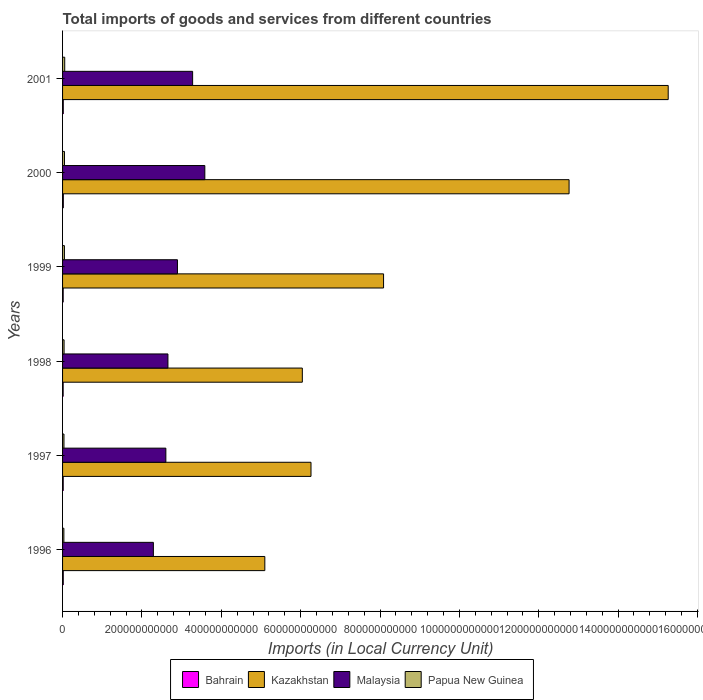How many groups of bars are there?
Give a very brief answer. 6. Are the number of bars per tick equal to the number of legend labels?
Provide a short and direct response. Yes. Are the number of bars on each tick of the Y-axis equal?
Your answer should be compact. Yes. How many bars are there on the 1st tick from the top?
Your response must be concise. 4. How many bars are there on the 5th tick from the bottom?
Offer a very short reply. 4. In how many cases, is the number of bars for a given year not equal to the number of legend labels?
Make the answer very short. 0. What is the Amount of goods and services imports in Papua New Guinea in 1998?
Give a very brief answer. 3.81e+09. Across all years, what is the maximum Amount of goods and services imports in Papua New Guinea?
Your response must be concise. 5.43e+09. Across all years, what is the minimum Amount of goods and services imports in Bahrain?
Offer a terse response. 1.49e+09. In which year was the Amount of goods and services imports in Kazakhstan maximum?
Make the answer very short. 2001. In which year was the Amount of goods and services imports in Malaysia minimum?
Keep it short and to the point. 1996. What is the total Amount of goods and services imports in Bahrain in the graph?
Give a very brief answer. 1.02e+1. What is the difference between the Amount of goods and services imports in Kazakhstan in 1997 and that in 1998?
Your answer should be very brief. 2.19e+1. What is the difference between the Amount of goods and services imports in Papua New Guinea in 1996 and the Amount of goods and services imports in Kazakhstan in 1999?
Provide a short and direct response. -8.06e+11. What is the average Amount of goods and services imports in Papua New Guinea per year?
Keep it short and to the point. 4.26e+09. In the year 2000, what is the difference between the Amount of goods and services imports in Malaysia and Amount of goods and services imports in Papua New Guinea?
Provide a short and direct response. 3.54e+11. In how many years, is the Amount of goods and services imports in Papua New Guinea greater than 1520000000000 LCU?
Your answer should be very brief. 0. What is the ratio of the Amount of goods and services imports in Papua New Guinea in 1996 to that in 2000?
Your response must be concise. 0.69. Is the difference between the Amount of goods and services imports in Malaysia in 1998 and 1999 greater than the difference between the Amount of goods and services imports in Papua New Guinea in 1998 and 1999?
Your answer should be very brief. No. What is the difference between the highest and the second highest Amount of goods and services imports in Papua New Guinea?
Offer a very short reply. 6.38e+08. What is the difference between the highest and the lowest Amount of goods and services imports in Kazakhstan?
Ensure brevity in your answer.  1.02e+12. Is the sum of the Amount of goods and services imports in Papua New Guinea in 1999 and 2000 greater than the maximum Amount of goods and services imports in Bahrain across all years?
Provide a succinct answer. Yes. What does the 3rd bar from the top in 1996 represents?
Offer a terse response. Kazakhstan. What does the 1st bar from the bottom in 2000 represents?
Provide a short and direct response. Bahrain. Is it the case that in every year, the sum of the Amount of goods and services imports in Kazakhstan and Amount of goods and services imports in Bahrain is greater than the Amount of goods and services imports in Malaysia?
Give a very brief answer. Yes. How many years are there in the graph?
Offer a very short reply. 6. What is the difference between two consecutive major ticks on the X-axis?
Provide a succinct answer. 2.00e+11. Does the graph contain any zero values?
Offer a very short reply. No. How are the legend labels stacked?
Provide a short and direct response. Horizontal. What is the title of the graph?
Ensure brevity in your answer.  Total imports of goods and services from different countries. What is the label or title of the X-axis?
Ensure brevity in your answer.  Imports (in Local Currency Unit). What is the label or title of the Y-axis?
Ensure brevity in your answer.  Years. What is the Imports (in Local Currency Unit) of Bahrain in 1996?
Your answer should be very brief. 1.75e+09. What is the Imports (in Local Currency Unit) in Kazakhstan in 1996?
Make the answer very short. 5.10e+11. What is the Imports (in Local Currency Unit) in Malaysia in 1996?
Your answer should be compact. 2.29e+11. What is the Imports (in Local Currency Unit) in Papua New Guinea in 1996?
Give a very brief answer. 3.29e+09. What is the Imports (in Local Currency Unit) of Bahrain in 1997?
Keep it short and to the point. 1.66e+09. What is the Imports (in Local Currency Unit) of Kazakhstan in 1997?
Provide a short and direct response. 6.26e+11. What is the Imports (in Local Currency Unit) in Malaysia in 1997?
Your answer should be very brief. 2.60e+11. What is the Imports (in Local Currency Unit) of Papua New Guinea in 1997?
Keep it short and to the point. 3.54e+09. What is the Imports (in Local Currency Unit) of Bahrain in 1998?
Ensure brevity in your answer.  1.49e+09. What is the Imports (in Local Currency Unit) in Kazakhstan in 1998?
Offer a terse response. 6.04e+11. What is the Imports (in Local Currency Unit) in Malaysia in 1998?
Keep it short and to the point. 2.66e+11. What is the Imports (in Local Currency Unit) in Papua New Guinea in 1998?
Provide a succinct answer. 3.81e+09. What is the Imports (in Local Currency Unit) of Bahrain in 1999?
Your response must be concise. 1.57e+09. What is the Imports (in Local Currency Unit) of Kazakhstan in 1999?
Offer a terse response. 8.09e+11. What is the Imports (in Local Currency Unit) in Malaysia in 1999?
Your answer should be very brief. 2.90e+11. What is the Imports (in Local Currency Unit) of Papua New Guinea in 1999?
Your answer should be very brief. 4.67e+09. What is the Imports (in Local Currency Unit) in Bahrain in 2000?
Ensure brevity in your answer.  1.93e+09. What is the Imports (in Local Currency Unit) in Kazakhstan in 2000?
Provide a short and direct response. 1.28e+12. What is the Imports (in Local Currency Unit) in Malaysia in 2000?
Ensure brevity in your answer.  3.59e+11. What is the Imports (in Local Currency Unit) in Papua New Guinea in 2000?
Provide a succinct answer. 4.79e+09. What is the Imports (in Local Currency Unit) in Bahrain in 2001?
Your response must be concise. 1.80e+09. What is the Imports (in Local Currency Unit) in Kazakhstan in 2001?
Your response must be concise. 1.53e+12. What is the Imports (in Local Currency Unit) in Malaysia in 2001?
Your response must be concise. 3.28e+11. What is the Imports (in Local Currency Unit) of Papua New Guinea in 2001?
Ensure brevity in your answer.  5.43e+09. Across all years, what is the maximum Imports (in Local Currency Unit) in Bahrain?
Your answer should be compact. 1.93e+09. Across all years, what is the maximum Imports (in Local Currency Unit) of Kazakhstan?
Make the answer very short. 1.53e+12. Across all years, what is the maximum Imports (in Local Currency Unit) of Malaysia?
Ensure brevity in your answer.  3.59e+11. Across all years, what is the maximum Imports (in Local Currency Unit) in Papua New Guinea?
Make the answer very short. 5.43e+09. Across all years, what is the minimum Imports (in Local Currency Unit) in Bahrain?
Your response must be concise. 1.49e+09. Across all years, what is the minimum Imports (in Local Currency Unit) in Kazakhstan?
Provide a short and direct response. 5.10e+11. Across all years, what is the minimum Imports (in Local Currency Unit) in Malaysia?
Provide a short and direct response. 2.29e+11. Across all years, what is the minimum Imports (in Local Currency Unit) of Papua New Guinea?
Ensure brevity in your answer.  3.29e+09. What is the total Imports (in Local Currency Unit) in Bahrain in the graph?
Ensure brevity in your answer.  1.02e+1. What is the total Imports (in Local Currency Unit) of Kazakhstan in the graph?
Offer a terse response. 5.35e+12. What is the total Imports (in Local Currency Unit) in Malaysia in the graph?
Offer a very short reply. 1.73e+12. What is the total Imports (in Local Currency Unit) of Papua New Guinea in the graph?
Make the answer very short. 2.55e+1. What is the difference between the Imports (in Local Currency Unit) in Bahrain in 1996 and that in 1997?
Give a very brief answer. 8.90e+07. What is the difference between the Imports (in Local Currency Unit) of Kazakhstan in 1996 and that in 1997?
Your response must be concise. -1.16e+11. What is the difference between the Imports (in Local Currency Unit) in Malaysia in 1996 and that in 1997?
Offer a terse response. -3.15e+1. What is the difference between the Imports (in Local Currency Unit) of Papua New Guinea in 1996 and that in 1997?
Keep it short and to the point. -2.55e+08. What is the difference between the Imports (in Local Currency Unit) of Bahrain in 1996 and that in 1998?
Give a very brief answer. 2.63e+08. What is the difference between the Imports (in Local Currency Unit) in Kazakhstan in 1996 and that in 1998?
Give a very brief answer. -9.45e+1. What is the difference between the Imports (in Local Currency Unit) of Malaysia in 1996 and that in 1998?
Your answer should be compact. -3.67e+1. What is the difference between the Imports (in Local Currency Unit) of Papua New Guinea in 1996 and that in 1998?
Provide a short and direct response. -5.21e+08. What is the difference between the Imports (in Local Currency Unit) of Bahrain in 1996 and that in 1999?
Offer a very short reply. 1.81e+08. What is the difference between the Imports (in Local Currency Unit) in Kazakhstan in 1996 and that in 1999?
Offer a very short reply. -2.99e+11. What is the difference between the Imports (in Local Currency Unit) in Malaysia in 1996 and that in 1999?
Your answer should be very brief. -6.07e+1. What is the difference between the Imports (in Local Currency Unit) of Papua New Guinea in 1996 and that in 1999?
Keep it short and to the point. -1.38e+09. What is the difference between the Imports (in Local Currency Unit) in Bahrain in 1996 and that in 2000?
Make the answer very short. -1.81e+08. What is the difference between the Imports (in Local Currency Unit) of Kazakhstan in 1996 and that in 2000?
Provide a succinct answer. -7.67e+11. What is the difference between the Imports (in Local Currency Unit) of Malaysia in 1996 and that in 2000?
Offer a terse response. -1.30e+11. What is the difference between the Imports (in Local Currency Unit) in Papua New Guinea in 1996 and that in 2000?
Make the answer very short. -1.51e+09. What is the difference between the Imports (in Local Currency Unit) of Bahrain in 1996 and that in 2001?
Give a very brief answer. -5.45e+07. What is the difference between the Imports (in Local Currency Unit) in Kazakhstan in 1996 and that in 2001?
Make the answer very short. -1.02e+12. What is the difference between the Imports (in Local Currency Unit) in Malaysia in 1996 and that in 2001?
Give a very brief answer. -9.89e+1. What is the difference between the Imports (in Local Currency Unit) in Papua New Guinea in 1996 and that in 2001?
Your response must be concise. -2.14e+09. What is the difference between the Imports (in Local Currency Unit) in Bahrain in 1997 and that in 1998?
Your answer should be compact. 1.74e+08. What is the difference between the Imports (in Local Currency Unit) in Kazakhstan in 1997 and that in 1998?
Ensure brevity in your answer.  2.19e+1. What is the difference between the Imports (in Local Currency Unit) in Malaysia in 1997 and that in 1998?
Keep it short and to the point. -5.23e+09. What is the difference between the Imports (in Local Currency Unit) in Papua New Guinea in 1997 and that in 1998?
Your answer should be compact. -2.66e+08. What is the difference between the Imports (in Local Currency Unit) of Bahrain in 1997 and that in 1999?
Your response must be concise. 9.18e+07. What is the difference between the Imports (in Local Currency Unit) in Kazakhstan in 1997 and that in 1999?
Offer a terse response. -1.83e+11. What is the difference between the Imports (in Local Currency Unit) in Malaysia in 1997 and that in 1999?
Offer a very short reply. -2.92e+1. What is the difference between the Imports (in Local Currency Unit) of Papua New Guinea in 1997 and that in 1999?
Your response must be concise. -1.13e+09. What is the difference between the Imports (in Local Currency Unit) in Bahrain in 1997 and that in 2000?
Make the answer very short. -2.70e+08. What is the difference between the Imports (in Local Currency Unit) of Kazakhstan in 1997 and that in 2000?
Your answer should be compact. -6.50e+11. What is the difference between the Imports (in Local Currency Unit) in Malaysia in 1997 and that in 2000?
Your response must be concise. -9.82e+1. What is the difference between the Imports (in Local Currency Unit) in Papua New Guinea in 1997 and that in 2000?
Make the answer very short. -1.25e+09. What is the difference between the Imports (in Local Currency Unit) of Bahrain in 1997 and that in 2001?
Keep it short and to the point. -1.44e+08. What is the difference between the Imports (in Local Currency Unit) of Kazakhstan in 1997 and that in 2001?
Your answer should be compact. -9.00e+11. What is the difference between the Imports (in Local Currency Unit) of Malaysia in 1997 and that in 2001?
Offer a terse response. -6.75e+1. What is the difference between the Imports (in Local Currency Unit) in Papua New Guinea in 1997 and that in 2001?
Offer a terse response. -1.89e+09. What is the difference between the Imports (in Local Currency Unit) of Bahrain in 1998 and that in 1999?
Give a very brief answer. -8.21e+07. What is the difference between the Imports (in Local Currency Unit) of Kazakhstan in 1998 and that in 1999?
Your response must be concise. -2.05e+11. What is the difference between the Imports (in Local Currency Unit) of Malaysia in 1998 and that in 1999?
Offer a very short reply. -2.40e+1. What is the difference between the Imports (in Local Currency Unit) of Papua New Guinea in 1998 and that in 1999?
Provide a succinct answer. -8.59e+08. What is the difference between the Imports (in Local Currency Unit) of Bahrain in 1998 and that in 2000?
Provide a succinct answer. -4.44e+08. What is the difference between the Imports (in Local Currency Unit) in Kazakhstan in 1998 and that in 2000?
Offer a very short reply. -6.72e+11. What is the difference between the Imports (in Local Currency Unit) in Malaysia in 1998 and that in 2000?
Provide a short and direct response. -9.30e+1. What is the difference between the Imports (in Local Currency Unit) in Papua New Guinea in 1998 and that in 2000?
Offer a very short reply. -9.85e+08. What is the difference between the Imports (in Local Currency Unit) in Bahrain in 1998 and that in 2001?
Your response must be concise. -3.17e+08. What is the difference between the Imports (in Local Currency Unit) in Kazakhstan in 1998 and that in 2001?
Your answer should be compact. -9.22e+11. What is the difference between the Imports (in Local Currency Unit) of Malaysia in 1998 and that in 2001?
Provide a short and direct response. -6.22e+1. What is the difference between the Imports (in Local Currency Unit) of Papua New Guinea in 1998 and that in 2001?
Ensure brevity in your answer.  -1.62e+09. What is the difference between the Imports (in Local Currency Unit) in Bahrain in 1999 and that in 2000?
Provide a short and direct response. -3.62e+08. What is the difference between the Imports (in Local Currency Unit) of Kazakhstan in 1999 and that in 2000?
Offer a terse response. -4.68e+11. What is the difference between the Imports (in Local Currency Unit) in Malaysia in 1999 and that in 2000?
Your answer should be compact. -6.90e+1. What is the difference between the Imports (in Local Currency Unit) in Papua New Guinea in 1999 and that in 2000?
Your answer should be compact. -1.25e+08. What is the difference between the Imports (in Local Currency Unit) in Bahrain in 1999 and that in 2001?
Offer a very short reply. -2.35e+08. What is the difference between the Imports (in Local Currency Unit) of Kazakhstan in 1999 and that in 2001?
Make the answer very short. -7.17e+11. What is the difference between the Imports (in Local Currency Unit) of Malaysia in 1999 and that in 2001?
Offer a very short reply. -3.83e+1. What is the difference between the Imports (in Local Currency Unit) of Papua New Guinea in 1999 and that in 2001?
Give a very brief answer. -7.63e+08. What is the difference between the Imports (in Local Currency Unit) in Bahrain in 2000 and that in 2001?
Provide a succinct answer. 1.27e+08. What is the difference between the Imports (in Local Currency Unit) of Kazakhstan in 2000 and that in 2001?
Your answer should be very brief. -2.50e+11. What is the difference between the Imports (in Local Currency Unit) of Malaysia in 2000 and that in 2001?
Ensure brevity in your answer.  3.08e+1. What is the difference between the Imports (in Local Currency Unit) in Papua New Guinea in 2000 and that in 2001?
Your response must be concise. -6.38e+08. What is the difference between the Imports (in Local Currency Unit) in Bahrain in 1996 and the Imports (in Local Currency Unit) in Kazakhstan in 1997?
Your answer should be very brief. -6.24e+11. What is the difference between the Imports (in Local Currency Unit) in Bahrain in 1996 and the Imports (in Local Currency Unit) in Malaysia in 1997?
Ensure brevity in your answer.  -2.59e+11. What is the difference between the Imports (in Local Currency Unit) of Bahrain in 1996 and the Imports (in Local Currency Unit) of Papua New Guinea in 1997?
Keep it short and to the point. -1.80e+09. What is the difference between the Imports (in Local Currency Unit) of Kazakhstan in 1996 and the Imports (in Local Currency Unit) of Malaysia in 1997?
Keep it short and to the point. 2.49e+11. What is the difference between the Imports (in Local Currency Unit) of Kazakhstan in 1996 and the Imports (in Local Currency Unit) of Papua New Guinea in 1997?
Your answer should be very brief. 5.06e+11. What is the difference between the Imports (in Local Currency Unit) in Malaysia in 1996 and the Imports (in Local Currency Unit) in Papua New Guinea in 1997?
Provide a succinct answer. 2.25e+11. What is the difference between the Imports (in Local Currency Unit) in Bahrain in 1996 and the Imports (in Local Currency Unit) in Kazakhstan in 1998?
Your answer should be compact. -6.02e+11. What is the difference between the Imports (in Local Currency Unit) of Bahrain in 1996 and the Imports (in Local Currency Unit) of Malaysia in 1998?
Provide a succinct answer. -2.64e+11. What is the difference between the Imports (in Local Currency Unit) in Bahrain in 1996 and the Imports (in Local Currency Unit) in Papua New Guinea in 1998?
Ensure brevity in your answer.  -2.06e+09. What is the difference between the Imports (in Local Currency Unit) of Kazakhstan in 1996 and the Imports (in Local Currency Unit) of Malaysia in 1998?
Provide a short and direct response. 2.44e+11. What is the difference between the Imports (in Local Currency Unit) of Kazakhstan in 1996 and the Imports (in Local Currency Unit) of Papua New Guinea in 1998?
Provide a succinct answer. 5.06e+11. What is the difference between the Imports (in Local Currency Unit) in Malaysia in 1996 and the Imports (in Local Currency Unit) in Papua New Guinea in 1998?
Your answer should be compact. 2.25e+11. What is the difference between the Imports (in Local Currency Unit) in Bahrain in 1996 and the Imports (in Local Currency Unit) in Kazakhstan in 1999?
Keep it short and to the point. -8.07e+11. What is the difference between the Imports (in Local Currency Unit) of Bahrain in 1996 and the Imports (in Local Currency Unit) of Malaysia in 1999?
Make the answer very short. -2.88e+11. What is the difference between the Imports (in Local Currency Unit) of Bahrain in 1996 and the Imports (in Local Currency Unit) of Papua New Guinea in 1999?
Keep it short and to the point. -2.92e+09. What is the difference between the Imports (in Local Currency Unit) in Kazakhstan in 1996 and the Imports (in Local Currency Unit) in Malaysia in 1999?
Ensure brevity in your answer.  2.20e+11. What is the difference between the Imports (in Local Currency Unit) of Kazakhstan in 1996 and the Imports (in Local Currency Unit) of Papua New Guinea in 1999?
Make the answer very short. 5.05e+11. What is the difference between the Imports (in Local Currency Unit) of Malaysia in 1996 and the Imports (in Local Currency Unit) of Papua New Guinea in 1999?
Keep it short and to the point. 2.24e+11. What is the difference between the Imports (in Local Currency Unit) of Bahrain in 1996 and the Imports (in Local Currency Unit) of Kazakhstan in 2000?
Your answer should be very brief. -1.27e+12. What is the difference between the Imports (in Local Currency Unit) of Bahrain in 1996 and the Imports (in Local Currency Unit) of Malaysia in 2000?
Keep it short and to the point. -3.57e+11. What is the difference between the Imports (in Local Currency Unit) of Bahrain in 1996 and the Imports (in Local Currency Unit) of Papua New Guinea in 2000?
Your response must be concise. -3.05e+09. What is the difference between the Imports (in Local Currency Unit) in Kazakhstan in 1996 and the Imports (in Local Currency Unit) in Malaysia in 2000?
Keep it short and to the point. 1.51e+11. What is the difference between the Imports (in Local Currency Unit) of Kazakhstan in 1996 and the Imports (in Local Currency Unit) of Papua New Guinea in 2000?
Give a very brief answer. 5.05e+11. What is the difference between the Imports (in Local Currency Unit) of Malaysia in 1996 and the Imports (in Local Currency Unit) of Papua New Guinea in 2000?
Make the answer very short. 2.24e+11. What is the difference between the Imports (in Local Currency Unit) in Bahrain in 1996 and the Imports (in Local Currency Unit) in Kazakhstan in 2001?
Your answer should be very brief. -1.52e+12. What is the difference between the Imports (in Local Currency Unit) of Bahrain in 1996 and the Imports (in Local Currency Unit) of Malaysia in 2001?
Keep it short and to the point. -3.26e+11. What is the difference between the Imports (in Local Currency Unit) in Bahrain in 1996 and the Imports (in Local Currency Unit) in Papua New Guinea in 2001?
Offer a terse response. -3.68e+09. What is the difference between the Imports (in Local Currency Unit) in Kazakhstan in 1996 and the Imports (in Local Currency Unit) in Malaysia in 2001?
Your answer should be very brief. 1.82e+11. What is the difference between the Imports (in Local Currency Unit) in Kazakhstan in 1996 and the Imports (in Local Currency Unit) in Papua New Guinea in 2001?
Give a very brief answer. 5.04e+11. What is the difference between the Imports (in Local Currency Unit) of Malaysia in 1996 and the Imports (in Local Currency Unit) of Papua New Guinea in 2001?
Ensure brevity in your answer.  2.23e+11. What is the difference between the Imports (in Local Currency Unit) in Bahrain in 1997 and the Imports (in Local Currency Unit) in Kazakhstan in 1998?
Provide a succinct answer. -6.03e+11. What is the difference between the Imports (in Local Currency Unit) in Bahrain in 1997 and the Imports (in Local Currency Unit) in Malaysia in 1998?
Offer a terse response. -2.64e+11. What is the difference between the Imports (in Local Currency Unit) in Bahrain in 1997 and the Imports (in Local Currency Unit) in Papua New Guinea in 1998?
Make the answer very short. -2.15e+09. What is the difference between the Imports (in Local Currency Unit) of Kazakhstan in 1997 and the Imports (in Local Currency Unit) of Malaysia in 1998?
Your response must be concise. 3.61e+11. What is the difference between the Imports (in Local Currency Unit) in Kazakhstan in 1997 and the Imports (in Local Currency Unit) in Papua New Guinea in 1998?
Offer a very short reply. 6.22e+11. What is the difference between the Imports (in Local Currency Unit) in Malaysia in 1997 and the Imports (in Local Currency Unit) in Papua New Guinea in 1998?
Offer a very short reply. 2.56e+11. What is the difference between the Imports (in Local Currency Unit) of Bahrain in 1997 and the Imports (in Local Currency Unit) of Kazakhstan in 1999?
Offer a terse response. -8.07e+11. What is the difference between the Imports (in Local Currency Unit) of Bahrain in 1997 and the Imports (in Local Currency Unit) of Malaysia in 1999?
Provide a short and direct response. -2.88e+11. What is the difference between the Imports (in Local Currency Unit) of Bahrain in 1997 and the Imports (in Local Currency Unit) of Papua New Guinea in 1999?
Keep it short and to the point. -3.01e+09. What is the difference between the Imports (in Local Currency Unit) in Kazakhstan in 1997 and the Imports (in Local Currency Unit) in Malaysia in 1999?
Make the answer very short. 3.37e+11. What is the difference between the Imports (in Local Currency Unit) in Kazakhstan in 1997 and the Imports (in Local Currency Unit) in Papua New Guinea in 1999?
Provide a succinct answer. 6.21e+11. What is the difference between the Imports (in Local Currency Unit) in Malaysia in 1997 and the Imports (in Local Currency Unit) in Papua New Guinea in 1999?
Provide a short and direct response. 2.56e+11. What is the difference between the Imports (in Local Currency Unit) of Bahrain in 1997 and the Imports (in Local Currency Unit) of Kazakhstan in 2000?
Your answer should be very brief. -1.27e+12. What is the difference between the Imports (in Local Currency Unit) of Bahrain in 1997 and the Imports (in Local Currency Unit) of Malaysia in 2000?
Provide a succinct answer. -3.57e+11. What is the difference between the Imports (in Local Currency Unit) in Bahrain in 1997 and the Imports (in Local Currency Unit) in Papua New Guinea in 2000?
Your answer should be very brief. -3.13e+09. What is the difference between the Imports (in Local Currency Unit) in Kazakhstan in 1997 and the Imports (in Local Currency Unit) in Malaysia in 2000?
Offer a terse response. 2.68e+11. What is the difference between the Imports (in Local Currency Unit) in Kazakhstan in 1997 and the Imports (in Local Currency Unit) in Papua New Guinea in 2000?
Give a very brief answer. 6.21e+11. What is the difference between the Imports (in Local Currency Unit) of Malaysia in 1997 and the Imports (in Local Currency Unit) of Papua New Guinea in 2000?
Keep it short and to the point. 2.56e+11. What is the difference between the Imports (in Local Currency Unit) of Bahrain in 1997 and the Imports (in Local Currency Unit) of Kazakhstan in 2001?
Your response must be concise. -1.52e+12. What is the difference between the Imports (in Local Currency Unit) of Bahrain in 1997 and the Imports (in Local Currency Unit) of Malaysia in 2001?
Offer a very short reply. -3.26e+11. What is the difference between the Imports (in Local Currency Unit) of Bahrain in 1997 and the Imports (in Local Currency Unit) of Papua New Guinea in 2001?
Your answer should be very brief. -3.77e+09. What is the difference between the Imports (in Local Currency Unit) of Kazakhstan in 1997 and the Imports (in Local Currency Unit) of Malaysia in 2001?
Ensure brevity in your answer.  2.98e+11. What is the difference between the Imports (in Local Currency Unit) of Kazakhstan in 1997 and the Imports (in Local Currency Unit) of Papua New Guinea in 2001?
Give a very brief answer. 6.21e+11. What is the difference between the Imports (in Local Currency Unit) in Malaysia in 1997 and the Imports (in Local Currency Unit) in Papua New Guinea in 2001?
Your answer should be very brief. 2.55e+11. What is the difference between the Imports (in Local Currency Unit) of Bahrain in 1998 and the Imports (in Local Currency Unit) of Kazakhstan in 1999?
Make the answer very short. -8.07e+11. What is the difference between the Imports (in Local Currency Unit) of Bahrain in 1998 and the Imports (in Local Currency Unit) of Malaysia in 1999?
Your answer should be very brief. -2.88e+11. What is the difference between the Imports (in Local Currency Unit) in Bahrain in 1998 and the Imports (in Local Currency Unit) in Papua New Guinea in 1999?
Give a very brief answer. -3.18e+09. What is the difference between the Imports (in Local Currency Unit) in Kazakhstan in 1998 and the Imports (in Local Currency Unit) in Malaysia in 1999?
Give a very brief answer. 3.15e+11. What is the difference between the Imports (in Local Currency Unit) of Kazakhstan in 1998 and the Imports (in Local Currency Unit) of Papua New Guinea in 1999?
Provide a succinct answer. 6.00e+11. What is the difference between the Imports (in Local Currency Unit) in Malaysia in 1998 and the Imports (in Local Currency Unit) in Papua New Guinea in 1999?
Provide a succinct answer. 2.61e+11. What is the difference between the Imports (in Local Currency Unit) of Bahrain in 1998 and the Imports (in Local Currency Unit) of Kazakhstan in 2000?
Give a very brief answer. -1.27e+12. What is the difference between the Imports (in Local Currency Unit) of Bahrain in 1998 and the Imports (in Local Currency Unit) of Malaysia in 2000?
Offer a terse response. -3.57e+11. What is the difference between the Imports (in Local Currency Unit) of Bahrain in 1998 and the Imports (in Local Currency Unit) of Papua New Guinea in 2000?
Provide a succinct answer. -3.31e+09. What is the difference between the Imports (in Local Currency Unit) in Kazakhstan in 1998 and the Imports (in Local Currency Unit) in Malaysia in 2000?
Give a very brief answer. 2.46e+11. What is the difference between the Imports (in Local Currency Unit) of Kazakhstan in 1998 and the Imports (in Local Currency Unit) of Papua New Guinea in 2000?
Your answer should be very brief. 5.99e+11. What is the difference between the Imports (in Local Currency Unit) of Malaysia in 1998 and the Imports (in Local Currency Unit) of Papua New Guinea in 2000?
Give a very brief answer. 2.61e+11. What is the difference between the Imports (in Local Currency Unit) in Bahrain in 1998 and the Imports (in Local Currency Unit) in Kazakhstan in 2001?
Keep it short and to the point. -1.52e+12. What is the difference between the Imports (in Local Currency Unit) in Bahrain in 1998 and the Imports (in Local Currency Unit) in Malaysia in 2001?
Offer a terse response. -3.26e+11. What is the difference between the Imports (in Local Currency Unit) of Bahrain in 1998 and the Imports (in Local Currency Unit) of Papua New Guinea in 2001?
Offer a terse response. -3.95e+09. What is the difference between the Imports (in Local Currency Unit) in Kazakhstan in 1998 and the Imports (in Local Currency Unit) in Malaysia in 2001?
Give a very brief answer. 2.76e+11. What is the difference between the Imports (in Local Currency Unit) in Kazakhstan in 1998 and the Imports (in Local Currency Unit) in Papua New Guinea in 2001?
Ensure brevity in your answer.  5.99e+11. What is the difference between the Imports (in Local Currency Unit) of Malaysia in 1998 and the Imports (in Local Currency Unit) of Papua New Guinea in 2001?
Offer a terse response. 2.60e+11. What is the difference between the Imports (in Local Currency Unit) of Bahrain in 1999 and the Imports (in Local Currency Unit) of Kazakhstan in 2000?
Your answer should be very brief. -1.27e+12. What is the difference between the Imports (in Local Currency Unit) in Bahrain in 1999 and the Imports (in Local Currency Unit) in Malaysia in 2000?
Provide a succinct answer. -3.57e+11. What is the difference between the Imports (in Local Currency Unit) in Bahrain in 1999 and the Imports (in Local Currency Unit) in Papua New Guinea in 2000?
Keep it short and to the point. -3.23e+09. What is the difference between the Imports (in Local Currency Unit) in Kazakhstan in 1999 and the Imports (in Local Currency Unit) in Malaysia in 2000?
Offer a terse response. 4.50e+11. What is the difference between the Imports (in Local Currency Unit) in Kazakhstan in 1999 and the Imports (in Local Currency Unit) in Papua New Guinea in 2000?
Give a very brief answer. 8.04e+11. What is the difference between the Imports (in Local Currency Unit) of Malaysia in 1999 and the Imports (in Local Currency Unit) of Papua New Guinea in 2000?
Your answer should be very brief. 2.85e+11. What is the difference between the Imports (in Local Currency Unit) in Bahrain in 1999 and the Imports (in Local Currency Unit) in Kazakhstan in 2001?
Offer a terse response. -1.52e+12. What is the difference between the Imports (in Local Currency Unit) of Bahrain in 1999 and the Imports (in Local Currency Unit) of Malaysia in 2001?
Offer a terse response. -3.26e+11. What is the difference between the Imports (in Local Currency Unit) in Bahrain in 1999 and the Imports (in Local Currency Unit) in Papua New Guinea in 2001?
Offer a terse response. -3.86e+09. What is the difference between the Imports (in Local Currency Unit) in Kazakhstan in 1999 and the Imports (in Local Currency Unit) in Malaysia in 2001?
Provide a succinct answer. 4.81e+11. What is the difference between the Imports (in Local Currency Unit) in Kazakhstan in 1999 and the Imports (in Local Currency Unit) in Papua New Guinea in 2001?
Give a very brief answer. 8.04e+11. What is the difference between the Imports (in Local Currency Unit) in Malaysia in 1999 and the Imports (in Local Currency Unit) in Papua New Guinea in 2001?
Provide a succinct answer. 2.84e+11. What is the difference between the Imports (in Local Currency Unit) of Bahrain in 2000 and the Imports (in Local Currency Unit) of Kazakhstan in 2001?
Provide a short and direct response. -1.52e+12. What is the difference between the Imports (in Local Currency Unit) in Bahrain in 2000 and the Imports (in Local Currency Unit) in Malaysia in 2001?
Your response must be concise. -3.26e+11. What is the difference between the Imports (in Local Currency Unit) in Bahrain in 2000 and the Imports (in Local Currency Unit) in Papua New Guinea in 2001?
Offer a terse response. -3.50e+09. What is the difference between the Imports (in Local Currency Unit) in Kazakhstan in 2000 and the Imports (in Local Currency Unit) in Malaysia in 2001?
Ensure brevity in your answer.  9.49e+11. What is the difference between the Imports (in Local Currency Unit) of Kazakhstan in 2000 and the Imports (in Local Currency Unit) of Papua New Guinea in 2001?
Your response must be concise. 1.27e+12. What is the difference between the Imports (in Local Currency Unit) of Malaysia in 2000 and the Imports (in Local Currency Unit) of Papua New Guinea in 2001?
Give a very brief answer. 3.53e+11. What is the average Imports (in Local Currency Unit) of Bahrain per year?
Provide a short and direct response. 1.70e+09. What is the average Imports (in Local Currency Unit) in Kazakhstan per year?
Provide a short and direct response. 8.92e+11. What is the average Imports (in Local Currency Unit) of Malaysia per year?
Keep it short and to the point. 2.88e+11. What is the average Imports (in Local Currency Unit) of Papua New Guinea per year?
Offer a very short reply. 4.26e+09. In the year 1996, what is the difference between the Imports (in Local Currency Unit) of Bahrain and Imports (in Local Currency Unit) of Kazakhstan?
Offer a very short reply. -5.08e+11. In the year 1996, what is the difference between the Imports (in Local Currency Unit) in Bahrain and Imports (in Local Currency Unit) in Malaysia?
Your answer should be compact. -2.27e+11. In the year 1996, what is the difference between the Imports (in Local Currency Unit) of Bahrain and Imports (in Local Currency Unit) of Papua New Guinea?
Provide a short and direct response. -1.54e+09. In the year 1996, what is the difference between the Imports (in Local Currency Unit) of Kazakhstan and Imports (in Local Currency Unit) of Malaysia?
Keep it short and to the point. 2.81e+11. In the year 1996, what is the difference between the Imports (in Local Currency Unit) in Kazakhstan and Imports (in Local Currency Unit) in Papua New Guinea?
Make the answer very short. 5.06e+11. In the year 1996, what is the difference between the Imports (in Local Currency Unit) in Malaysia and Imports (in Local Currency Unit) in Papua New Guinea?
Give a very brief answer. 2.26e+11. In the year 1997, what is the difference between the Imports (in Local Currency Unit) in Bahrain and Imports (in Local Currency Unit) in Kazakhstan?
Provide a succinct answer. -6.24e+11. In the year 1997, what is the difference between the Imports (in Local Currency Unit) of Bahrain and Imports (in Local Currency Unit) of Malaysia?
Ensure brevity in your answer.  -2.59e+11. In the year 1997, what is the difference between the Imports (in Local Currency Unit) in Bahrain and Imports (in Local Currency Unit) in Papua New Guinea?
Your answer should be compact. -1.88e+09. In the year 1997, what is the difference between the Imports (in Local Currency Unit) in Kazakhstan and Imports (in Local Currency Unit) in Malaysia?
Ensure brevity in your answer.  3.66e+11. In the year 1997, what is the difference between the Imports (in Local Currency Unit) in Kazakhstan and Imports (in Local Currency Unit) in Papua New Guinea?
Your answer should be compact. 6.23e+11. In the year 1997, what is the difference between the Imports (in Local Currency Unit) of Malaysia and Imports (in Local Currency Unit) of Papua New Guinea?
Make the answer very short. 2.57e+11. In the year 1998, what is the difference between the Imports (in Local Currency Unit) in Bahrain and Imports (in Local Currency Unit) in Kazakhstan?
Offer a very short reply. -6.03e+11. In the year 1998, what is the difference between the Imports (in Local Currency Unit) of Bahrain and Imports (in Local Currency Unit) of Malaysia?
Ensure brevity in your answer.  -2.64e+11. In the year 1998, what is the difference between the Imports (in Local Currency Unit) of Bahrain and Imports (in Local Currency Unit) of Papua New Guinea?
Provide a succinct answer. -2.32e+09. In the year 1998, what is the difference between the Imports (in Local Currency Unit) of Kazakhstan and Imports (in Local Currency Unit) of Malaysia?
Your answer should be very brief. 3.39e+11. In the year 1998, what is the difference between the Imports (in Local Currency Unit) in Kazakhstan and Imports (in Local Currency Unit) in Papua New Guinea?
Ensure brevity in your answer.  6.00e+11. In the year 1998, what is the difference between the Imports (in Local Currency Unit) of Malaysia and Imports (in Local Currency Unit) of Papua New Guinea?
Provide a short and direct response. 2.62e+11. In the year 1999, what is the difference between the Imports (in Local Currency Unit) in Bahrain and Imports (in Local Currency Unit) in Kazakhstan?
Give a very brief answer. -8.07e+11. In the year 1999, what is the difference between the Imports (in Local Currency Unit) of Bahrain and Imports (in Local Currency Unit) of Malaysia?
Give a very brief answer. -2.88e+11. In the year 1999, what is the difference between the Imports (in Local Currency Unit) in Bahrain and Imports (in Local Currency Unit) in Papua New Guinea?
Provide a short and direct response. -3.10e+09. In the year 1999, what is the difference between the Imports (in Local Currency Unit) of Kazakhstan and Imports (in Local Currency Unit) of Malaysia?
Your answer should be very brief. 5.19e+11. In the year 1999, what is the difference between the Imports (in Local Currency Unit) of Kazakhstan and Imports (in Local Currency Unit) of Papua New Guinea?
Ensure brevity in your answer.  8.04e+11. In the year 1999, what is the difference between the Imports (in Local Currency Unit) in Malaysia and Imports (in Local Currency Unit) in Papua New Guinea?
Keep it short and to the point. 2.85e+11. In the year 2000, what is the difference between the Imports (in Local Currency Unit) of Bahrain and Imports (in Local Currency Unit) of Kazakhstan?
Provide a succinct answer. -1.27e+12. In the year 2000, what is the difference between the Imports (in Local Currency Unit) of Bahrain and Imports (in Local Currency Unit) of Malaysia?
Provide a succinct answer. -3.57e+11. In the year 2000, what is the difference between the Imports (in Local Currency Unit) in Bahrain and Imports (in Local Currency Unit) in Papua New Guinea?
Make the answer very short. -2.86e+09. In the year 2000, what is the difference between the Imports (in Local Currency Unit) of Kazakhstan and Imports (in Local Currency Unit) of Malaysia?
Provide a succinct answer. 9.18e+11. In the year 2000, what is the difference between the Imports (in Local Currency Unit) in Kazakhstan and Imports (in Local Currency Unit) in Papua New Guinea?
Offer a very short reply. 1.27e+12. In the year 2000, what is the difference between the Imports (in Local Currency Unit) in Malaysia and Imports (in Local Currency Unit) in Papua New Guinea?
Your answer should be very brief. 3.54e+11. In the year 2001, what is the difference between the Imports (in Local Currency Unit) in Bahrain and Imports (in Local Currency Unit) in Kazakhstan?
Keep it short and to the point. -1.52e+12. In the year 2001, what is the difference between the Imports (in Local Currency Unit) in Bahrain and Imports (in Local Currency Unit) in Malaysia?
Keep it short and to the point. -3.26e+11. In the year 2001, what is the difference between the Imports (in Local Currency Unit) in Bahrain and Imports (in Local Currency Unit) in Papua New Guinea?
Keep it short and to the point. -3.63e+09. In the year 2001, what is the difference between the Imports (in Local Currency Unit) of Kazakhstan and Imports (in Local Currency Unit) of Malaysia?
Ensure brevity in your answer.  1.20e+12. In the year 2001, what is the difference between the Imports (in Local Currency Unit) of Kazakhstan and Imports (in Local Currency Unit) of Papua New Guinea?
Provide a succinct answer. 1.52e+12. In the year 2001, what is the difference between the Imports (in Local Currency Unit) of Malaysia and Imports (in Local Currency Unit) of Papua New Guinea?
Keep it short and to the point. 3.22e+11. What is the ratio of the Imports (in Local Currency Unit) in Bahrain in 1996 to that in 1997?
Offer a terse response. 1.05. What is the ratio of the Imports (in Local Currency Unit) of Kazakhstan in 1996 to that in 1997?
Offer a terse response. 0.81. What is the ratio of the Imports (in Local Currency Unit) in Malaysia in 1996 to that in 1997?
Ensure brevity in your answer.  0.88. What is the ratio of the Imports (in Local Currency Unit) of Papua New Guinea in 1996 to that in 1997?
Your answer should be compact. 0.93. What is the ratio of the Imports (in Local Currency Unit) in Bahrain in 1996 to that in 1998?
Give a very brief answer. 1.18. What is the ratio of the Imports (in Local Currency Unit) in Kazakhstan in 1996 to that in 1998?
Make the answer very short. 0.84. What is the ratio of the Imports (in Local Currency Unit) of Malaysia in 1996 to that in 1998?
Your answer should be very brief. 0.86. What is the ratio of the Imports (in Local Currency Unit) of Papua New Guinea in 1996 to that in 1998?
Provide a short and direct response. 0.86. What is the ratio of the Imports (in Local Currency Unit) in Bahrain in 1996 to that in 1999?
Your response must be concise. 1.12. What is the ratio of the Imports (in Local Currency Unit) in Kazakhstan in 1996 to that in 1999?
Your response must be concise. 0.63. What is the ratio of the Imports (in Local Currency Unit) of Malaysia in 1996 to that in 1999?
Give a very brief answer. 0.79. What is the ratio of the Imports (in Local Currency Unit) of Papua New Guinea in 1996 to that in 1999?
Ensure brevity in your answer.  0.7. What is the ratio of the Imports (in Local Currency Unit) of Bahrain in 1996 to that in 2000?
Provide a succinct answer. 0.91. What is the ratio of the Imports (in Local Currency Unit) of Kazakhstan in 1996 to that in 2000?
Your answer should be compact. 0.4. What is the ratio of the Imports (in Local Currency Unit) of Malaysia in 1996 to that in 2000?
Keep it short and to the point. 0.64. What is the ratio of the Imports (in Local Currency Unit) in Papua New Guinea in 1996 to that in 2000?
Provide a succinct answer. 0.69. What is the ratio of the Imports (in Local Currency Unit) of Bahrain in 1996 to that in 2001?
Your response must be concise. 0.97. What is the ratio of the Imports (in Local Currency Unit) of Kazakhstan in 1996 to that in 2001?
Your response must be concise. 0.33. What is the ratio of the Imports (in Local Currency Unit) of Malaysia in 1996 to that in 2001?
Offer a terse response. 0.7. What is the ratio of the Imports (in Local Currency Unit) of Papua New Guinea in 1996 to that in 2001?
Your answer should be compact. 0.61. What is the ratio of the Imports (in Local Currency Unit) of Bahrain in 1997 to that in 1998?
Offer a terse response. 1.12. What is the ratio of the Imports (in Local Currency Unit) in Kazakhstan in 1997 to that in 1998?
Offer a very short reply. 1.04. What is the ratio of the Imports (in Local Currency Unit) of Malaysia in 1997 to that in 1998?
Your response must be concise. 0.98. What is the ratio of the Imports (in Local Currency Unit) in Papua New Guinea in 1997 to that in 1998?
Keep it short and to the point. 0.93. What is the ratio of the Imports (in Local Currency Unit) in Bahrain in 1997 to that in 1999?
Your answer should be very brief. 1.06. What is the ratio of the Imports (in Local Currency Unit) of Kazakhstan in 1997 to that in 1999?
Keep it short and to the point. 0.77. What is the ratio of the Imports (in Local Currency Unit) of Malaysia in 1997 to that in 1999?
Give a very brief answer. 0.9. What is the ratio of the Imports (in Local Currency Unit) of Papua New Guinea in 1997 to that in 1999?
Keep it short and to the point. 0.76. What is the ratio of the Imports (in Local Currency Unit) in Bahrain in 1997 to that in 2000?
Offer a terse response. 0.86. What is the ratio of the Imports (in Local Currency Unit) in Kazakhstan in 1997 to that in 2000?
Keep it short and to the point. 0.49. What is the ratio of the Imports (in Local Currency Unit) in Malaysia in 1997 to that in 2000?
Ensure brevity in your answer.  0.73. What is the ratio of the Imports (in Local Currency Unit) in Papua New Guinea in 1997 to that in 2000?
Give a very brief answer. 0.74. What is the ratio of the Imports (in Local Currency Unit) in Bahrain in 1997 to that in 2001?
Ensure brevity in your answer.  0.92. What is the ratio of the Imports (in Local Currency Unit) in Kazakhstan in 1997 to that in 2001?
Ensure brevity in your answer.  0.41. What is the ratio of the Imports (in Local Currency Unit) of Malaysia in 1997 to that in 2001?
Ensure brevity in your answer.  0.79. What is the ratio of the Imports (in Local Currency Unit) in Papua New Guinea in 1997 to that in 2001?
Give a very brief answer. 0.65. What is the ratio of the Imports (in Local Currency Unit) of Bahrain in 1998 to that in 1999?
Ensure brevity in your answer.  0.95. What is the ratio of the Imports (in Local Currency Unit) in Kazakhstan in 1998 to that in 1999?
Ensure brevity in your answer.  0.75. What is the ratio of the Imports (in Local Currency Unit) in Malaysia in 1998 to that in 1999?
Keep it short and to the point. 0.92. What is the ratio of the Imports (in Local Currency Unit) in Papua New Guinea in 1998 to that in 1999?
Ensure brevity in your answer.  0.82. What is the ratio of the Imports (in Local Currency Unit) of Bahrain in 1998 to that in 2000?
Make the answer very short. 0.77. What is the ratio of the Imports (in Local Currency Unit) in Kazakhstan in 1998 to that in 2000?
Make the answer very short. 0.47. What is the ratio of the Imports (in Local Currency Unit) of Malaysia in 1998 to that in 2000?
Offer a terse response. 0.74. What is the ratio of the Imports (in Local Currency Unit) of Papua New Guinea in 1998 to that in 2000?
Keep it short and to the point. 0.79. What is the ratio of the Imports (in Local Currency Unit) of Bahrain in 1998 to that in 2001?
Your answer should be compact. 0.82. What is the ratio of the Imports (in Local Currency Unit) of Kazakhstan in 1998 to that in 2001?
Offer a very short reply. 0.4. What is the ratio of the Imports (in Local Currency Unit) in Malaysia in 1998 to that in 2001?
Provide a short and direct response. 0.81. What is the ratio of the Imports (in Local Currency Unit) of Papua New Guinea in 1998 to that in 2001?
Give a very brief answer. 0.7. What is the ratio of the Imports (in Local Currency Unit) in Bahrain in 1999 to that in 2000?
Keep it short and to the point. 0.81. What is the ratio of the Imports (in Local Currency Unit) of Kazakhstan in 1999 to that in 2000?
Ensure brevity in your answer.  0.63. What is the ratio of the Imports (in Local Currency Unit) in Malaysia in 1999 to that in 2000?
Provide a short and direct response. 0.81. What is the ratio of the Imports (in Local Currency Unit) of Papua New Guinea in 1999 to that in 2000?
Offer a terse response. 0.97. What is the ratio of the Imports (in Local Currency Unit) in Bahrain in 1999 to that in 2001?
Ensure brevity in your answer.  0.87. What is the ratio of the Imports (in Local Currency Unit) in Kazakhstan in 1999 to that in 2001?
Make the answer very short. 0.53. What is the ratio of the Imports (in Local Currency Unit) in Malaysia in 1999 to that in 2001?
Make the answer very short. 0.88. What is the ratio of the Imports (in Local Currency Unit) of Papua New Guinea in 1999 to that in 2001?
Offer a terse response. 0.86. What is the ratio of the Imports (in Local Currency Unit) of Bahrain in 2000 to that in 2001?
Provide a succinct answer. 1.07. What is the ratio of the Imports (in Local Currency Unit) of Kazakhstan in 2000 to that in 2001?
Provide a short and direct response. 0.84. What is the ratio of the Imports (in Local Currency Unit) of Malaysia in 2000 to that in 2001?
Ensure brevity in your answer.  1.09. What is the ratio of the Imports (in Local Currency Unit) in Papua New Guinea in 2000 to that in 2001?
Offer a very short reply. 0.88. What is the difference between the highest and the second highest Imports (in Local Currency Unit) of Bahrain?
Your response must be concise. 1.27e+08. What is the difference between the highest and the second highest Imports (in Local Currency Unit) of Kazakhstan?
Offer a terse response. 2.50e+11. What is the difference between the highest and the second highest Imports (in Local Currency Unit) in Malaysia?
Give a very brief answer. 3.08e+1. What is the difference between the highest and the second highest Imports (in Local Currency Unit) in Papua New Guinea?
Your answer should be compact. 6.38e+08. What is the difference between the highest and the lowest Imports (in Local Currency Unit) of Bahrain?
Your answer should be compact. 4.44e+08. What is the difference between the highest and the lowest Imports (in Local Currency Unit) of Kazakhstan?
Ensure brevity in your answer.  1.02e+12. What is the difference between the highest and the lowest Imports (in Local Currency Unit) in Malaysia?
Give a very brief answer. 1.30e+11. What is the difference between the highest and the lowest Imports (in Local Currency Unit) of Papua New Guinea?
Provide a succinct answer. 2.14e+09. 